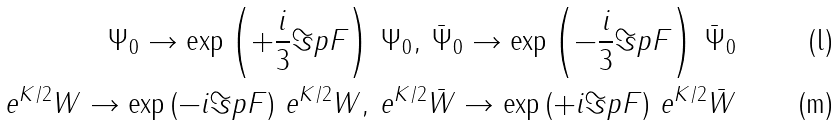Convert formula to latex. <formula><loc_0><loc_0><loc_500><loc_500>\Psi _ { 0 } \rightarrow \exp \left ( + \frac { i } { 3 } \Im p F \right ) \, \Psi _ { 0 } , \, \bar { \Psi } _ { 0 } \rightarrow \exp \left ( - \frac { i } { 3 } \Im p F \right ) \, \bar { \Psi } _ { 0 } \\ e ^ { K / 2 } W \rightarrow \exp \left ( - i \Im p F \right ) \, e ^ { K / 2 } W , \, e ^ { K / 2 } \bar { W } \rightarrow \exp \left ( + i \Im p F \right ) \, e ^ { K / 2 } \bar { W }</formula> 